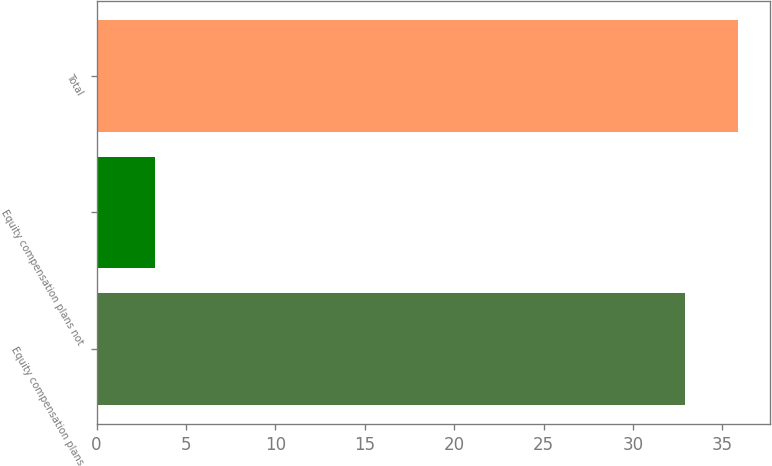Convert chart. <chart><loc_0><loc_0><loc_500><loc_500><bar_chart><fcel>Equity compensation plans<fcel>Equity compensation plans not<fcel>Total<nl><fcel>32.91<fcel>3.25<fcel>35.88<nl></chart> 